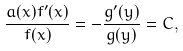Convert formula to latex. <formula><loc_0><loc_0><loc_500><loc_500>\frac { a ( x ) f ^ { \prime } ( x ) } { f ( x ) } = - \frac { g ^ { \prime } ( y ) } { g ( y ) } = C ,</formula> 